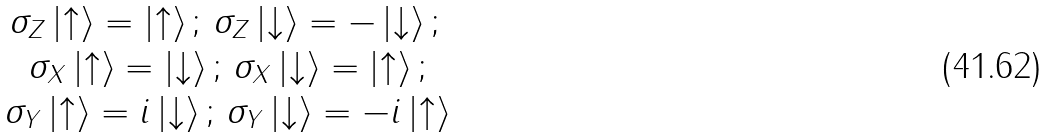Convert formula to latex. <formula><loc_0><loc_0><loc_500><loc_500>\begin{array} { c c } \sigma _ { Z } \left | \uparrow \right \rangle = \left | \uparrow \right \rangle ; \, \sigma _ { Z } \left | \downarrow \right \rangle = - \left | \downarrow \right \rangle ; \, \\ \sigma _ { X } \left | \uparrow \right \rangle = \left | \downarrow \right \rangle ; \, \sigma _ { X } \left | \downarrow \right \rangle = \left | \uparrow \right \rangle ; \\ \sigma _ { Y } \left | \uparrow \right \rangle = i \left | \downarrow \right \rangle ; \, \sigma _ { Y } \left | \downarrow \right \rangle = - i \left | \uparrow \right \rangle \\ \end{array}</formula> 